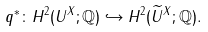<formula> <loc_0><loc_0><loc_500><loc_500>q ^ { * } \colon H ^ { 2 } ( U ^ { X } ; \mathbb { Q } ) \hookrightarrow H ^ { 2 } ( \widetilde { U } ^ { X } ; \mathbb { Q } ) .</formula> 